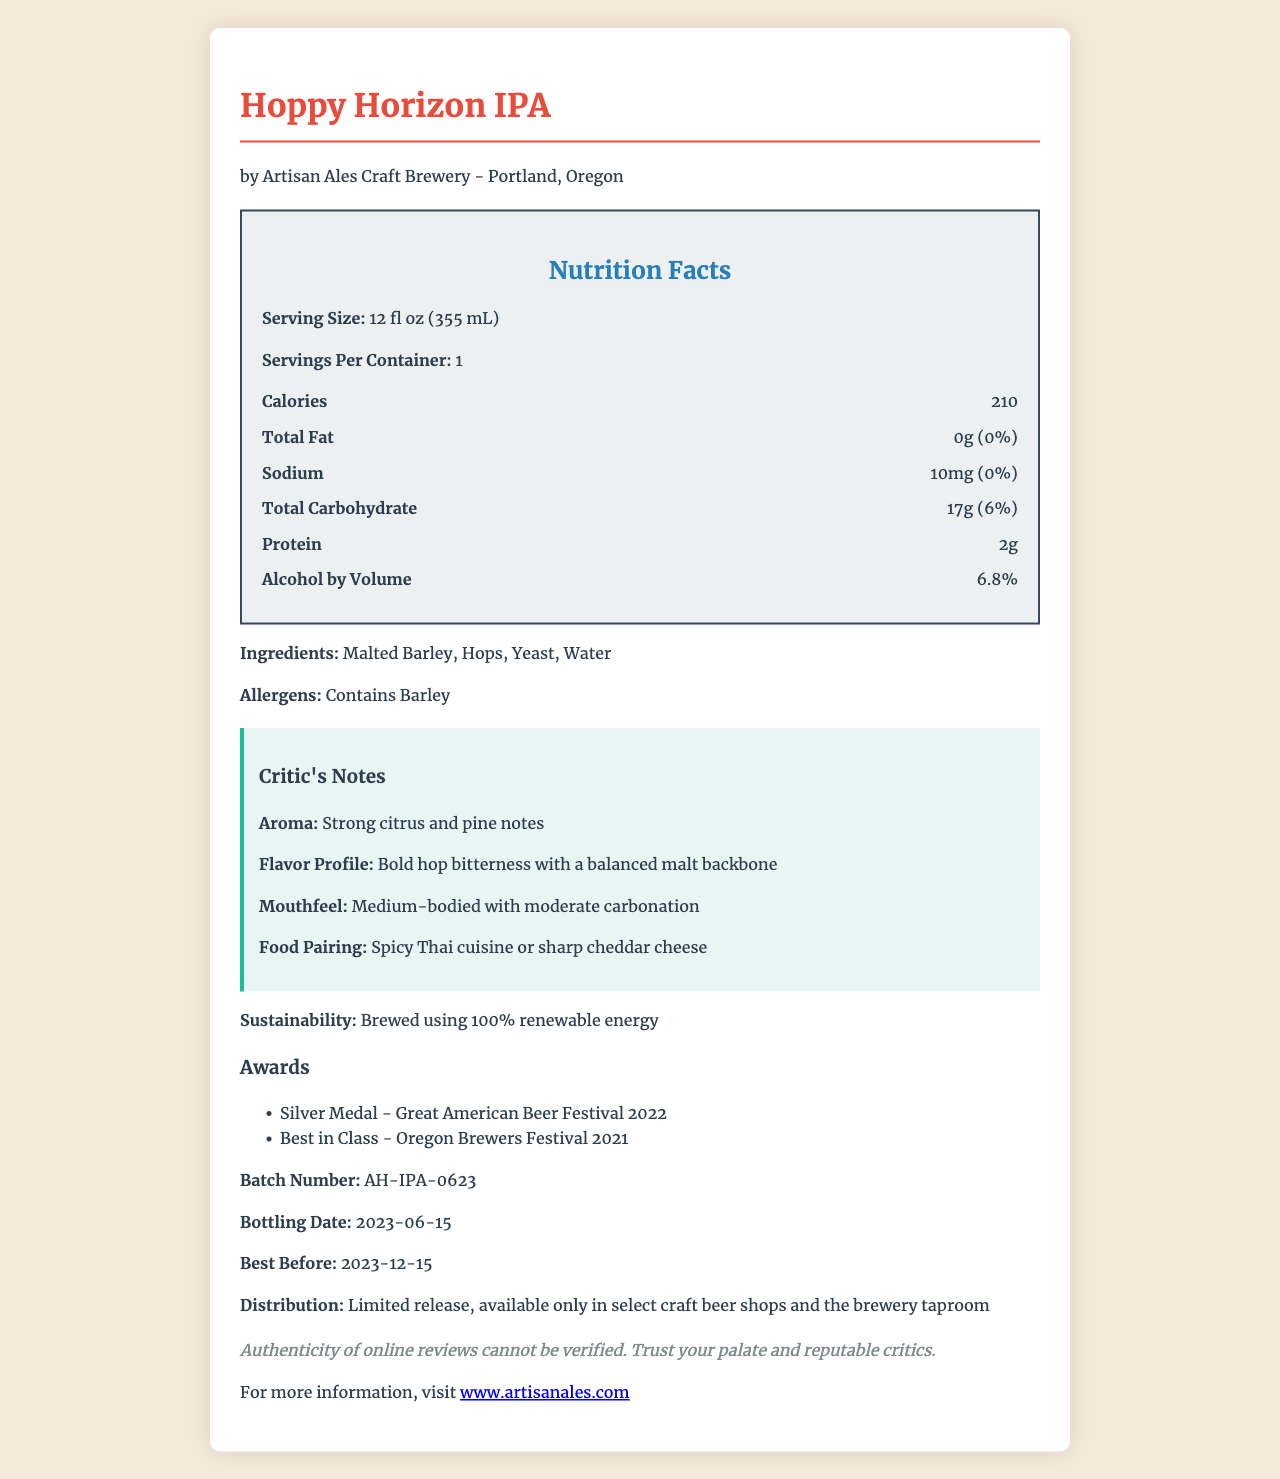what is the calorie content per serving? The document lists the calorie content as being 210 per 12 fl oz (355 mL) serving.
Answer: 210 calories what is the serving size of the Hoppy Horizon IPA? The document states that the serving size for Hoppy Horizon IPA is 12 fl oz (355 mL).
Answer: 12 fl oz (355 mL) how much protein does this beer contain? The nutrition facts label indicates that the beer contains 2 grams of protein per serving.
Answer: 2g what is the percentage of alcohol by volume in the Hoppy Horizon IPA? The alcohol by volume (ABV) for Hoppy Horizon IPA is specified as 6.8% on the label.
Answer: 6.8% which brewery produced this craft beer? The brewery name is given as Artisan Ales Craft Brewery based in Portland, Oregon.
Answer: Artisan Ales Craft Brewery what is the best before date for this beer? The best before date mentioned in the document is December 15, 2023.
Answer: 2023-12-15 which of the following is NOT an ingredient of the Hoppy Horizon IPA? 1. Malted Barley 2. Corn Syrup 3. Hops 4. Yeast 5. Water The ingredients listed are Malted Barley, Hops, Yeast, and Water. Corn Syrup is not mentioned among the ingredients.
Answer: 2. Corn Syrup which award has the Hoppy Horizon IPA won? A. Gold Medal - Great American Beer Festival 2022 B. Silver Medal - Great American Beer Festival 2022 C. Best in Show - National Brewers Expo 2021 The document mentions that Hoppy Horizon IPA won the Silver Medal at the Great American Beer Festival in 2022.
Answer: B. Silver Medal - Great American Beer Festival 2022 does the beer contain any allergens? The label specifically states that the beer contains Barley, which is an allergen.
Answer: Yes summarize the critical information about Hoppy Horizon IPA found in the document The summary captures key aspects such as the brewery, alcohol content, calorie count, awards, sustainability information, flavor profile, pairing suggestions, ingredients, allergens, and best-before date.
Answer: Hoppy Horizon IPA is a craft beer brewed by Artisan Ales Craft Brewery in Portland, Oregon, with an alcohol by volume (ABV) of 6.8% and 210 calories per 12 fl oz serving. The beer won the Silver Medal at the Great American Beer Festival in 2022 and is brewed using 100% renewable energy. The flavor profile includes strong citrus and pine aromas, and it is best paired with spicy Thai cuisine or sharp cheddar cheese. It is brewed with ingredients including Malted Barley, Hops, Yeast, and Water, and it contains Barley as an allergen. The best-before date is December 15, 2023. how many milligrams of sodium does the Hoppy Horizon IPA contain? The document states that the beer contains 10 milligrams of sodium per serving.
Answer: 10mg what sustainable practice is mentioned in the document regarding the brewing process? According to the document, the beer is brewed using 100% renewable energy.
Answer: Brewed using 100% renewable energy what does the document say about the authenticity of online reviews? The document includes a disclaimer regarding the authenticity of social media reviews, advising consumers to trust their own palate and reputable critics.
Answer: Authenticity of online reviews cannot be verified. Trust your palate and reputable critics. what is the bottling date of this craft beer? The bottling date provided in the document is June 15, 2023.
Answer: 2023-06-15 how does the critic describe the mouthfeel of Hoppy Horizon IPA? The critic notes that the beer has a medium-bodied mouthfeel with moderate carbonation.
Answer: Medium-bodied with moderate carbonation what are the distribution details provided for Hoppy Horizon IPA? The document specifies that the beer is a limited release and can only be found in select craft beer shops and the brewery taproom.
Answer: Limited release, available only in select craft beer shops and the brewery taproom what types of hops are used in Hoppy Horizon IPA? The document mentions that hops are used but does not specify the types of hops.
Answer: Not enough information 